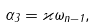<formula> <loc_0><loc_0><loc_500><loc_500>\alpha _ { 3 } = \varkappa \omega _ { n - 1 } ,</formula> 